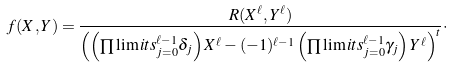<formula> <loc_0><loc_0><loc_500><loc_500>f ( X , Y ) = \frac { R ( X ^ { \ell } , Y ^ { \ell } ) } { { \left ( \left ( \prod \lim i t s _ { j = 0 } ^ { \ell - 1 } { \delta _ { j } } \right ) X ^ { \ell } - ( - 1 ) ^ { \ell - 1 } \left ( \prod \lim i t s _ { j = 0 } ^ { \ell - 1 } { \gamma _ { j } } \right ) Y ^ { \ell } \right ) } ^ { t } } \cdot</formula> 